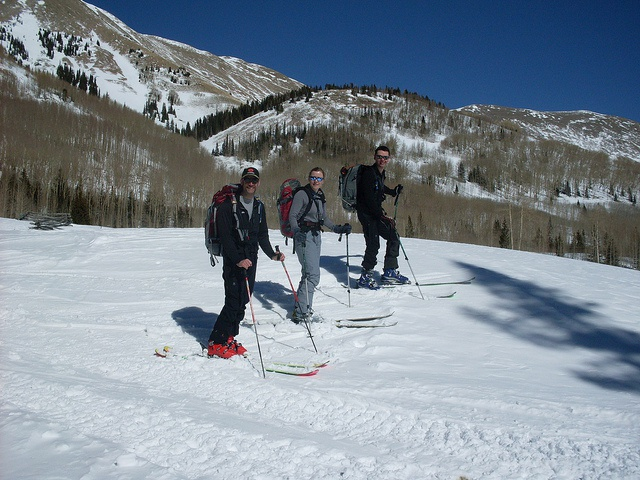Describe the objects in this image and their specific colors. I can see people in gray, black, maroon, and brown tones, people in gray, black, navy, and blue tones, people in gray, black, and blue tones, backpack in gray, black, maroon, and purple tones, and skis in gray, lightgray, and darkgray tones in this image. 